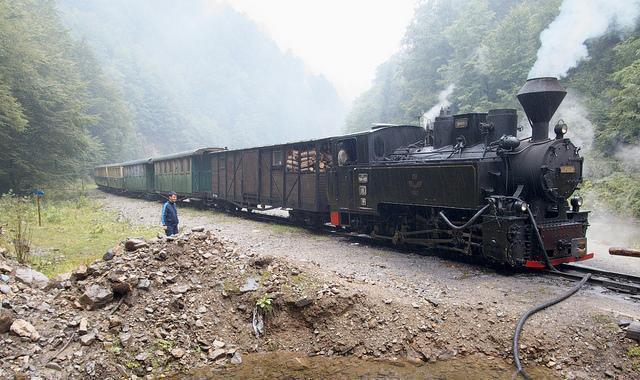What is being used to maintain the steam engine's momentum?
From the following four choices, select the correct answer to address the question.
Options: Wood, coal, steel, electricity. Wood. 